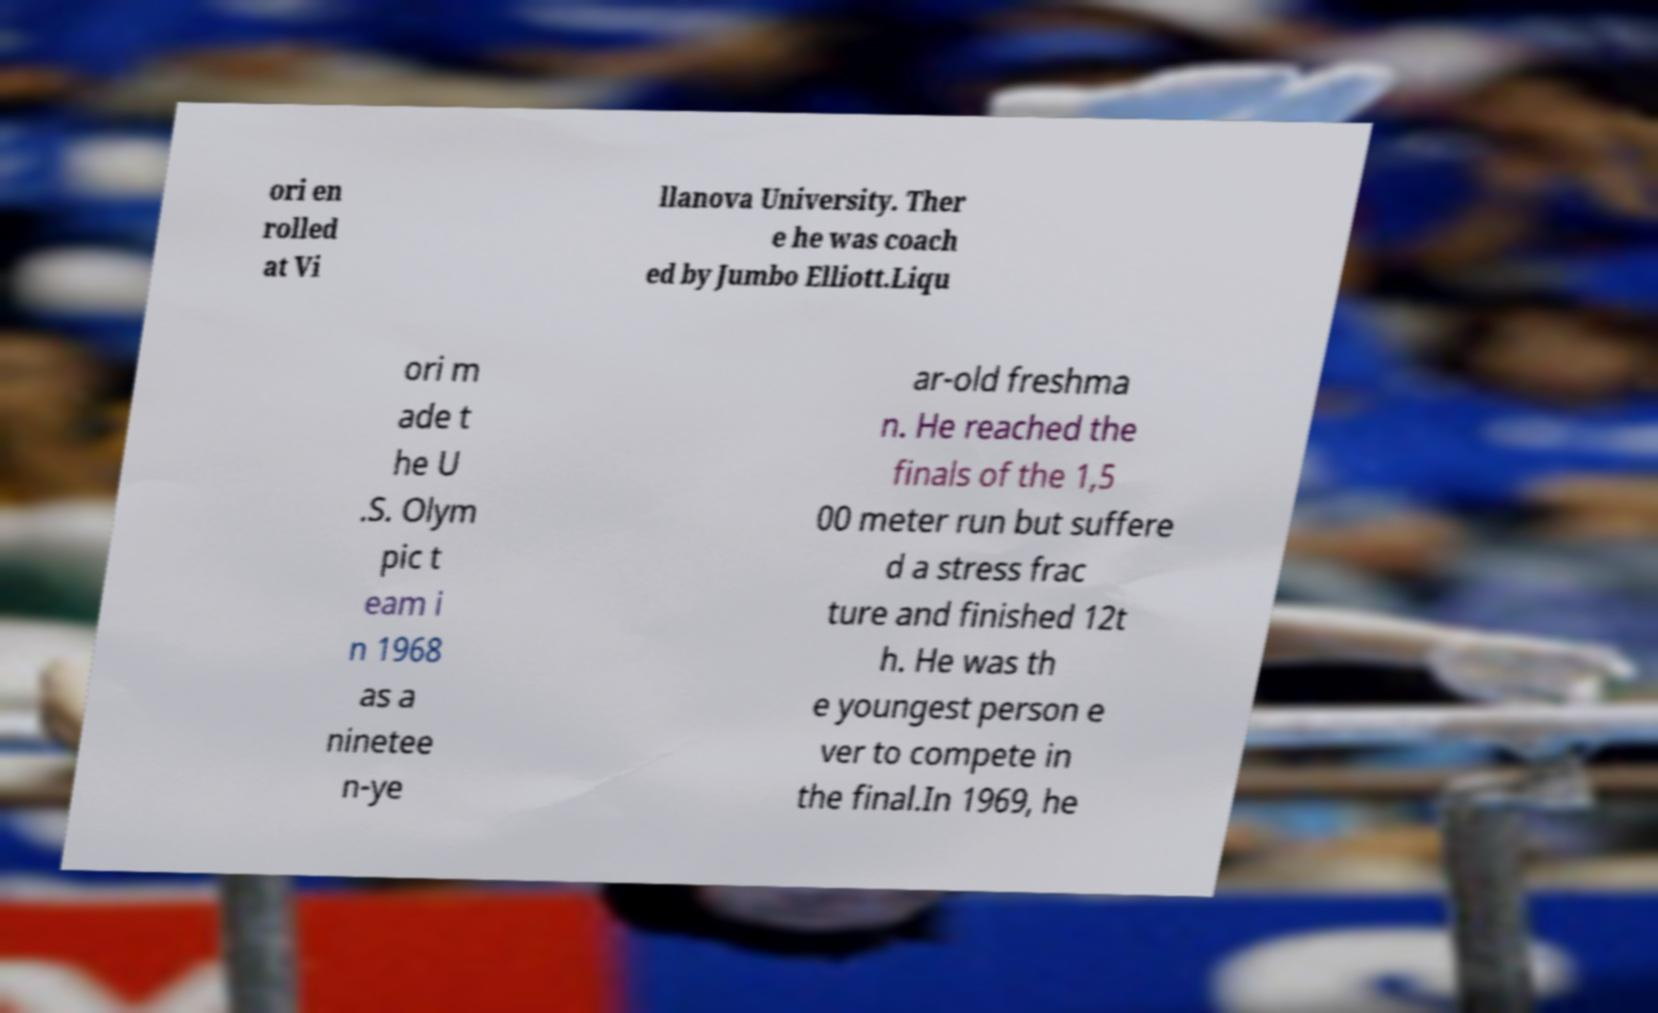What messages or text are displayed in this image? I need them in a readable, typed format. ori en rolled at Vi llanova University. Ther e he was coach ed by Jumbo Elliott.Liqu ori m ade t he U .S. Olym pic t eam i n 1968 as a ninetee n-ye ar-old freshma n. He reached the finals of the 1,5 00 meter run but suffere d a stress frac ture and finished 12t h. He was th e youngest person e ver to compete in the final.In 1969, he 